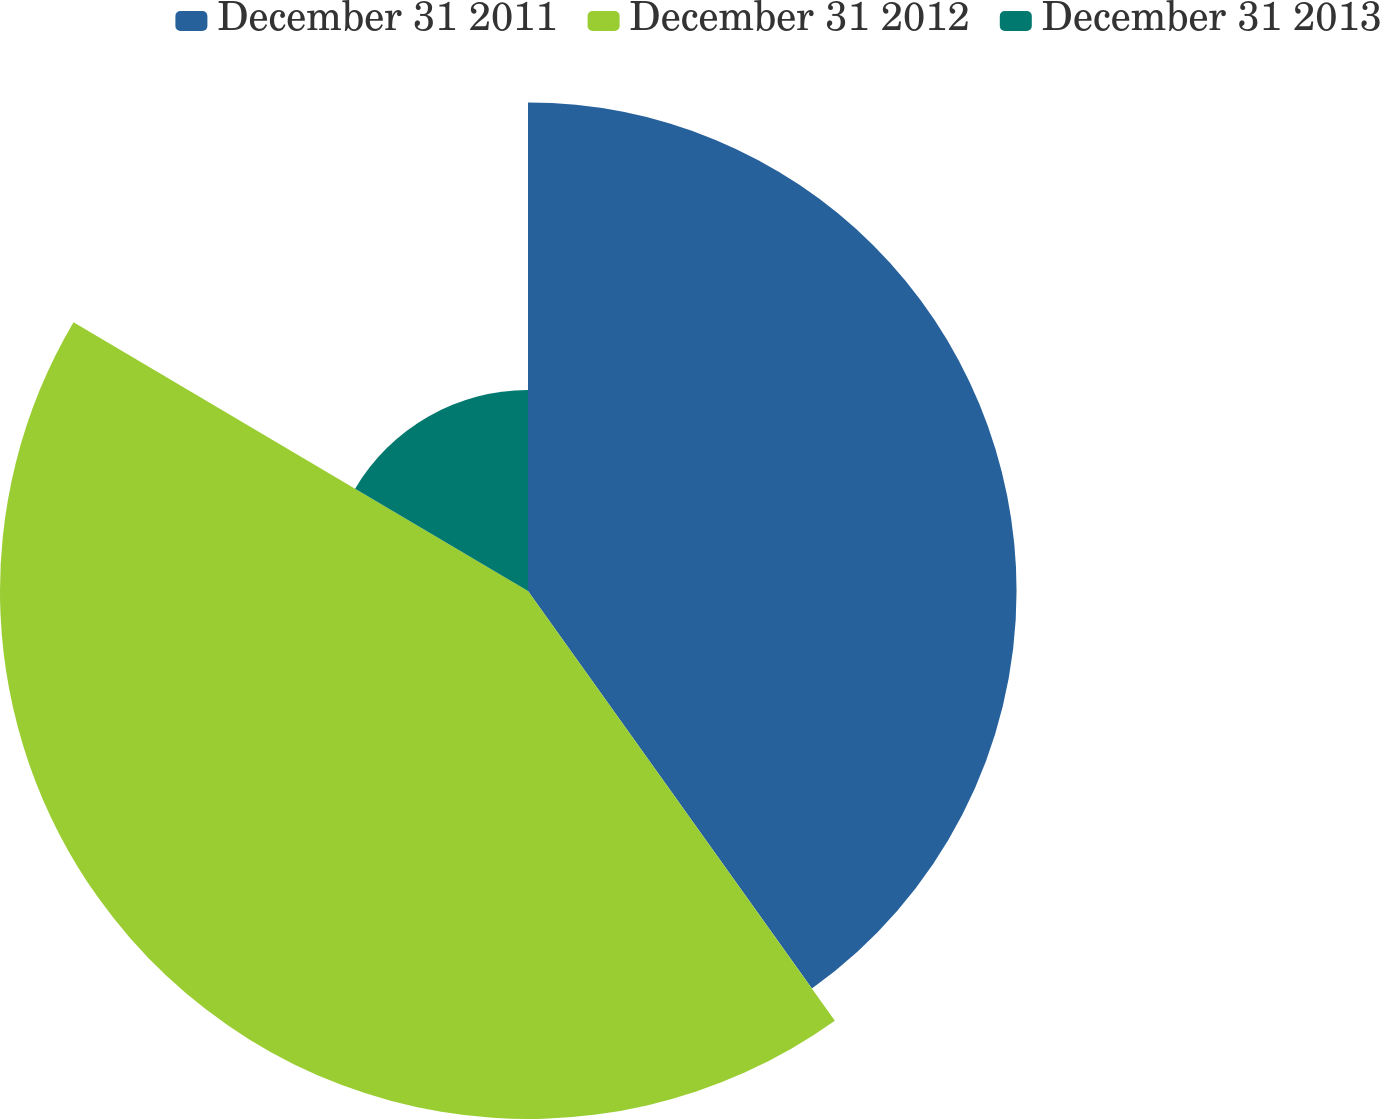Convert chart. <chart><loc_0><loc_0><loc_500><loc_500><pie_chart><fcel>December 31 2011<fcel>December 31 2012<fcel>December 31 2013<nl><fcel>40.13%<fcel>43.37%<fcel>16.5%<nl></chart> 